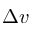<formula> <loc_0><loc_0><loc_500><loc_500>\Delta v</formula> 